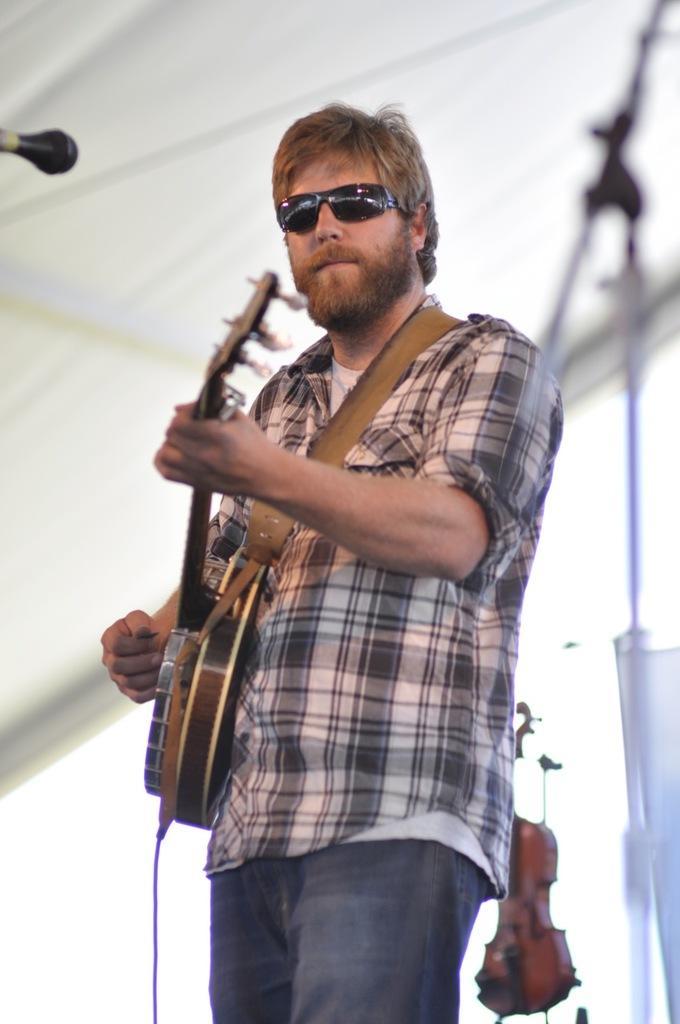How would you summarize this image in a sentence or two? In the image we can see there is a man who is standing and he is holding guitar in his hand. 